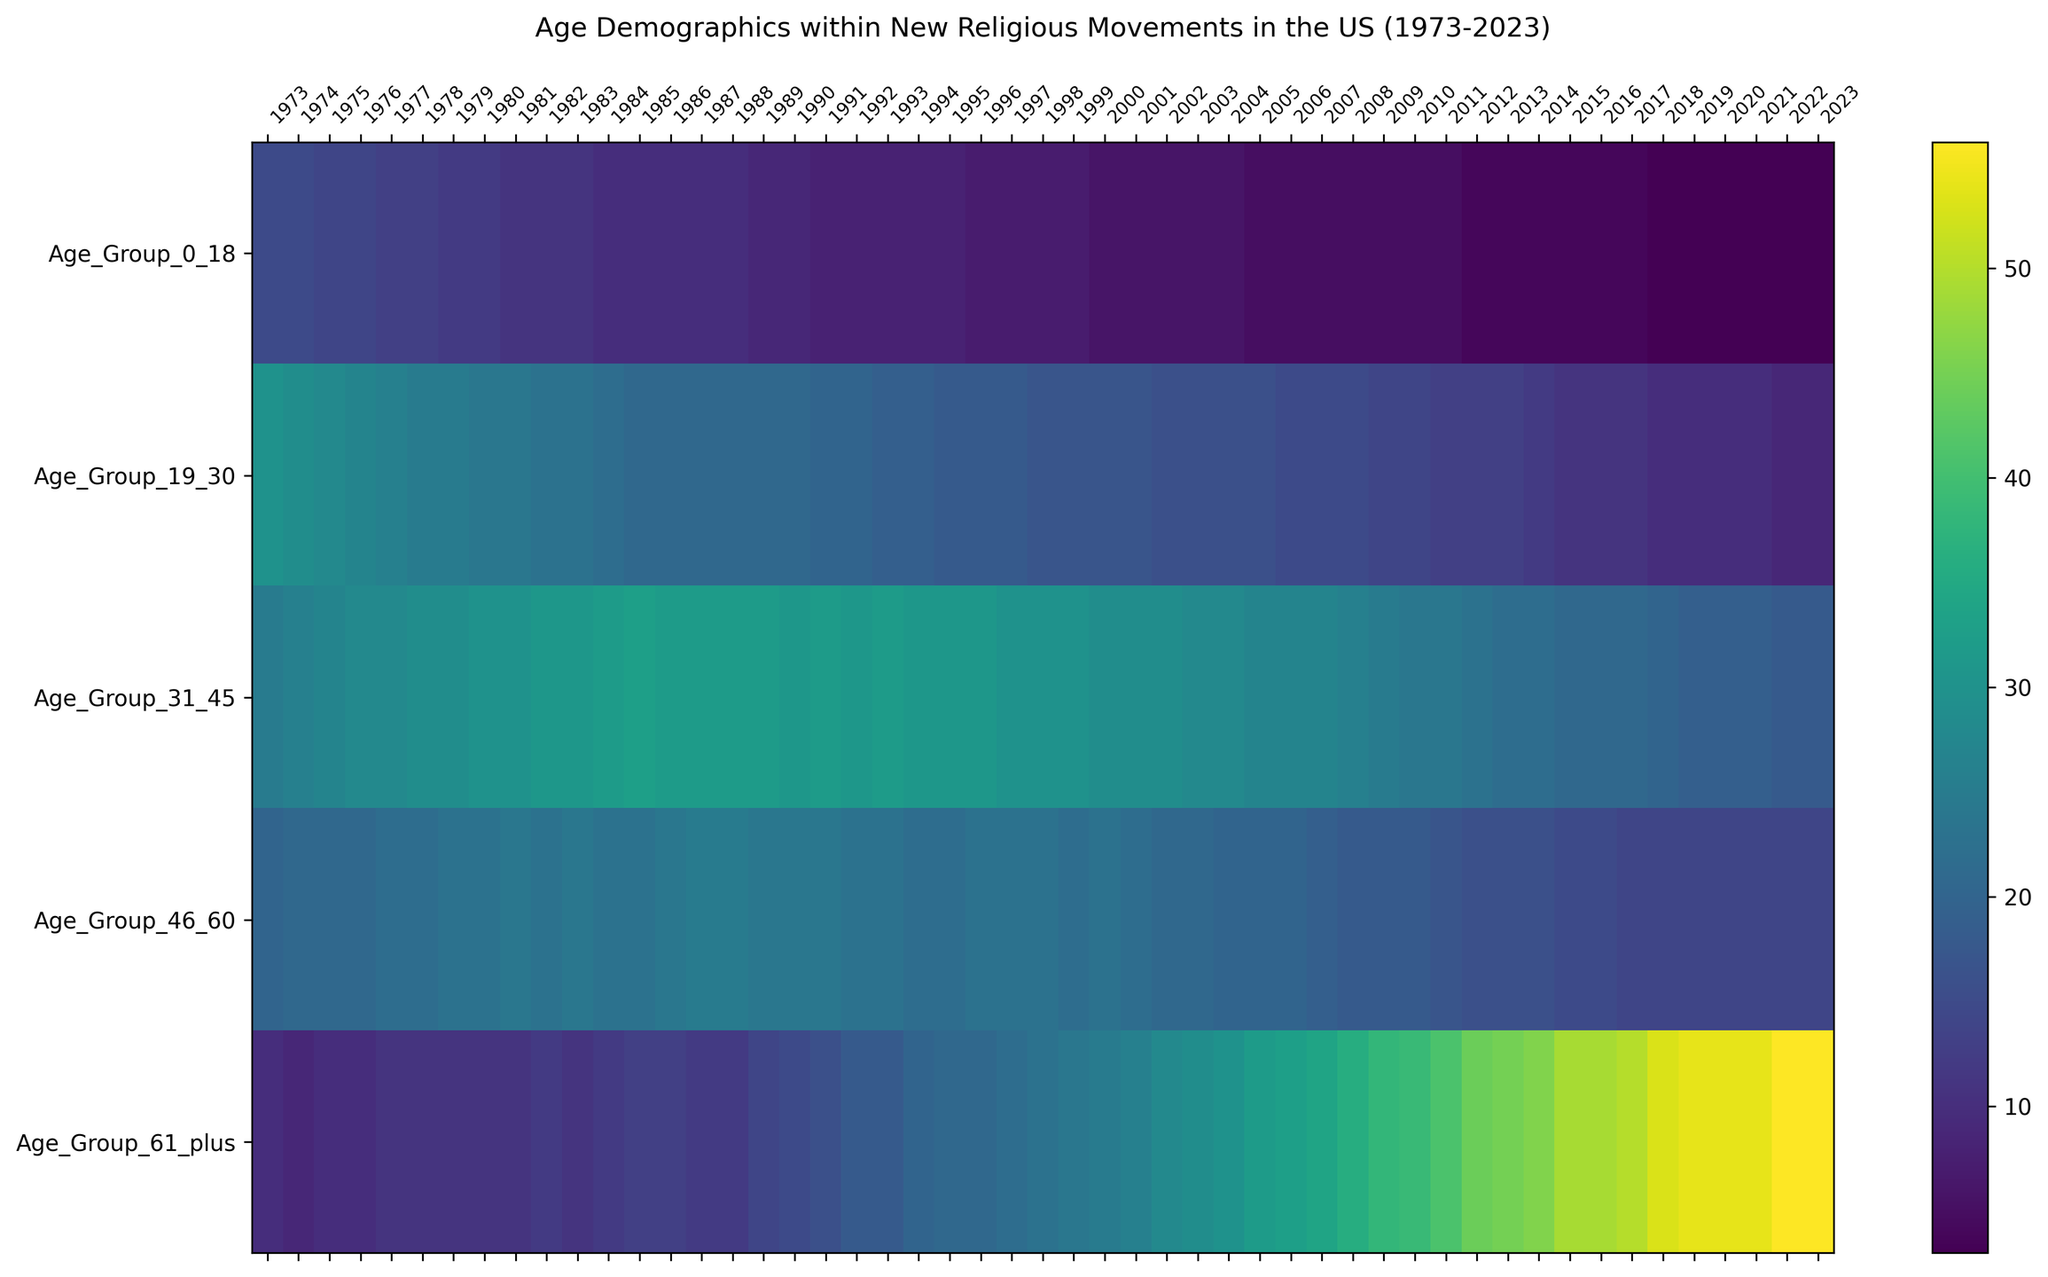How has the proportion of the 61+ age group changed from 1973 to 2023? By comparing the 61+ age group's values from 1973 and 2023 in the heatmap, the proportion has clearly increased. In 1973, the value was 10, and in 2023, it is 56, indicating a significant rise over the 50-year period.
Answer: The proportion increased from 10 to 56 Between which years did the age group 31-45 see the highest proportion value? By examining the heatmap, the highest value for the 31-45 age group can be seen between 1985 and 1997, where the value is 33 in 1985.
Answer: 1985 Which age group experienced the most noticeable decrease in proportion over the span of 50 years? By visually scanning the heatmap for steep declines, the 19-30 age group shows a marked decrease from 30 in 1973 to 9 in 2023.
Answer: 19-30 age group What was the average proportion of the 0-18 age group during the 1990s? To calculate the average, sum the values from 1990 to 1999: 9 (1990) + 8 (1991) + 8 (1992) + 8 (1993) + 8 (1994) + 8 (1995) + 7 (1996) + 7 (1997) + 7 (1998) + 7 (1999) = 77. Then, divide by 10 (years): 77/10 = 7.7.
Answer: 7.7 What is the overall trend for the age group 46-60 from 1973 to 2023? By observing the heatmap, the age group 46-60 shows an overall increase. The value starts at 20 in 1973, with fluctuations, and increases to 14 in 2023.
Answer: General increase Which age group had the least change in proportion over the 50 years? By evaluating the fluctuations across the heatmap, the 0-18 age group exhibits the least change, starting at a value of 15 in 1973 and reducing to 3 in 2023.
Answer: 0-18 age group During which decade did the age group 61+ see its most rapid increase? By examining the gradient of color changes, the age group 61+ shows the most rapid increase between 2010 and 2020, rising from 39 to 54.
Answer: 2010-2020 How does the proportion of the 46-60 age group in 2000 compare with that in 2020? By comparing the values directly from the heatmap, in 2000, the value is 23, and in 2020, the value is 14.
Answer: Decreased from 23 to 14 